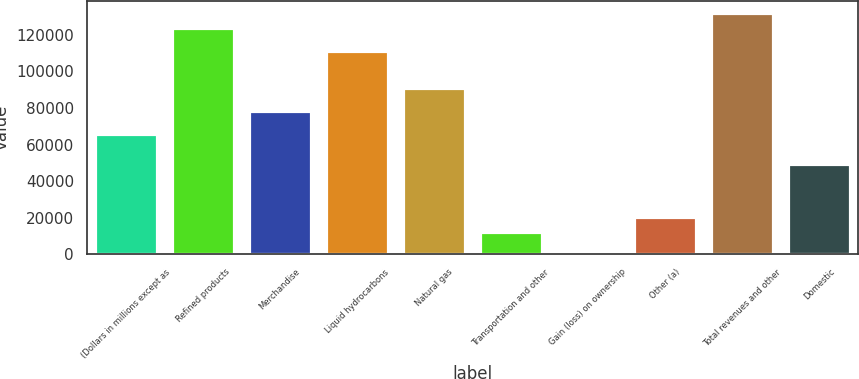<chart> <loc_0><loc_0><loc_500><loc_500><bar_chart><fcel>(Dollars in millions except as<fcel>Refined products<fcel>Merchandise<fcel>Liquid hydrocarbons<fcel>Natural gas<fcel>Transportation and other<fcel>Gain (loss) on ownership<fcel>Other (a)<fcel>Total revenues and other<fcel>Domestic<nl><fcel>65973.8<fcel>123700<fcel>78343.7<fcel>111330<fcel>90713.6<fcel>12370.9<fcel>1<fcel>20617.5<fcel>131947<fcel>49480.6<nl></chart> 